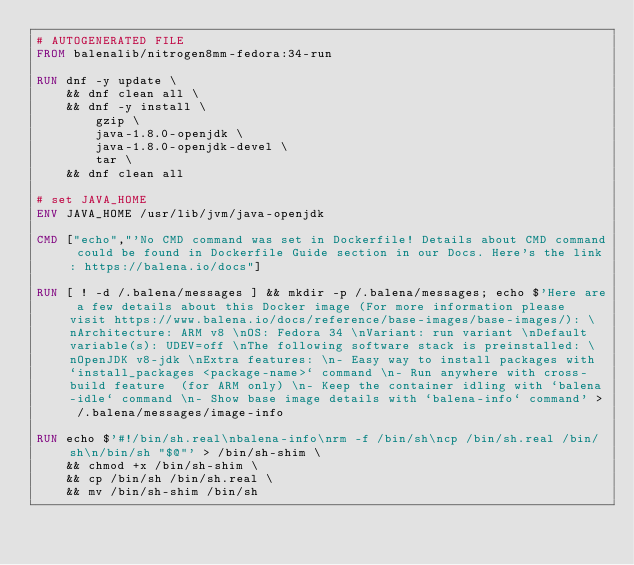<code> <loc_0><loc_0><loc_500><loc_500><_Dockerfile_># AUTOGENERATED FILE
FROM balenalib/nitrogen8mm-fedora:34-run

RUN dnf -y update \
	&& dnf clean all \
	&& dnf -y install \
		gzip \
		java-1.8.0-openjdk \
		java-1.8.0-openjdk-devel \
		tar \
	&& dnf clean all

# set JAVA_HOME
ENV JAVA_HOME /usr/lib/jvm/java-openjdk

CMD ["echo","'No CMD command was set in Dockerfile! Details about CMD command could be found in Dockerfile Guide section in our Docs. Here's the link: https://balena.io/docs"]

RUN [ ! -d /.balena/messages ] && mkdir -p /.balena/messages; echo $'Here are a few details about this Docker image (For more information please visit https://www.balena.io/docs/reference/base-images/base-images/): \nArchitecture: ARM v8 \nOS: Fedora 34 \nVariant: run variant \nDefault variable(s): UDEV=off \nThe following software stack is preinstalled: \nOpenJDK v8-jdk \nExtra features: \n- Easy way to install packages with `install_packages <package-name>` command \n- Run anywhere with cross-build feature  (for ARM only) \n- Keep the container idling with `balena-idle` command \n- Show base image details with `balena-info` command' > /.balena/messages/image-info

RUN echo $'#!/bin/sh.real\nbalena-info\nrm -f /bin/sh\ncp /bin/sh.real /bin/sh\n/bin/sh "$@"' > /bin/sh-shim \
	&& chmod +x /bin/sh-shim \
	&& cp /bin/sh /bin/sh.real \
	&& mv /bin/sh-shim /bin/sh</code> 